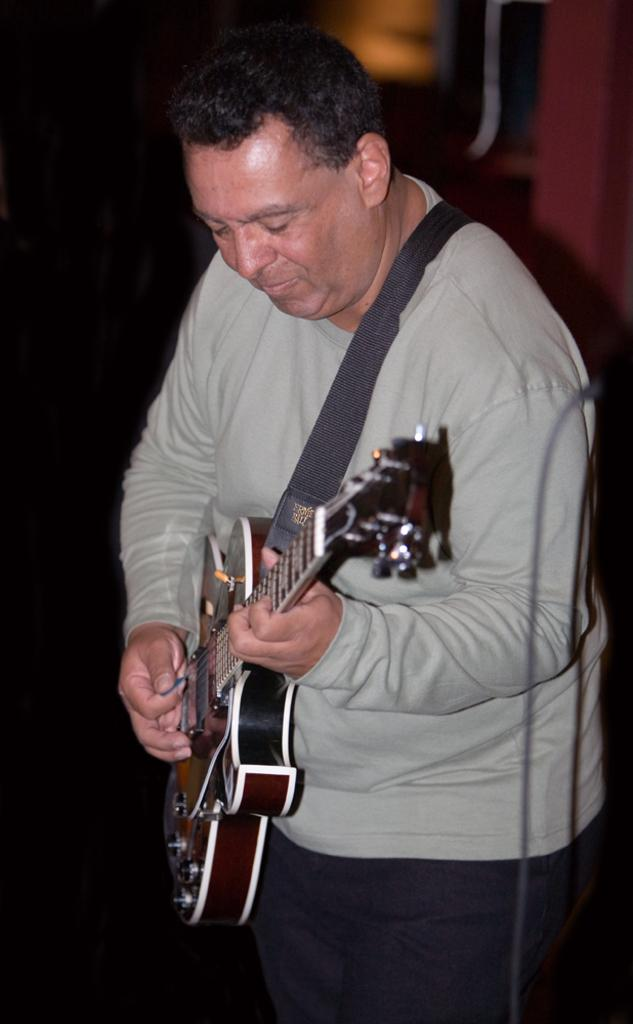What is the main subject of the image? The main subject of the image is a man. Can you describe what the man is wearing? The man is wearing a grey costume. What object is the man holding in the image? The man is holding a guitar. What is the man doing with the guitar? The man is playing the guitar. What type of bead is the man using to play the guitar in the image? There is no bead present in the image; the man is playing the guitar with his hands. How many marbles are visible in the image? There are no marbles present in the image. 